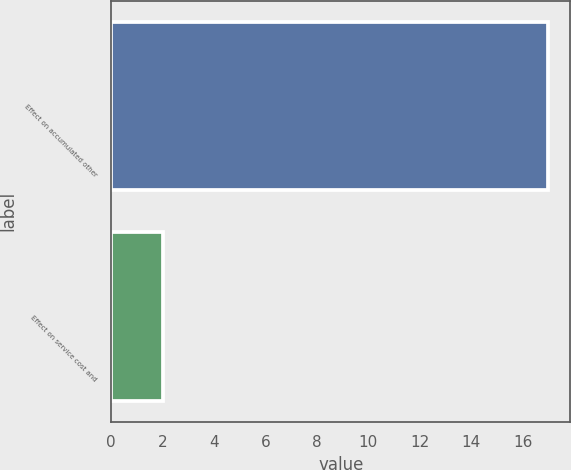Convert chart. <chart><loc_0><loc_0><loc_500><loc_500><bar_chart><fcel>Effect on accumulated other<fcel>Effect on service cost and<nl><fcel>17<fcel>2<nl></chart> 